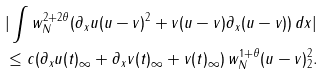Convert formula to latex. <formula><loc_0><loc_0><loc_500><loc_500>& | \int w _ { N } ^ { 2 + 2 \theta } ( \partial _ { x } u ( u - v ) ^ { 2 } + v ( u - v ) \partial _ { x } ( u - v ) ) \, d x | \\ & \leq c ( \| \partial _ { x } u ( t ) \| _ { \infty } + \| \partial _ { x } v ( t ) \| _ { \infty } + \| v ( t ) \| _ { \infty } ) \, \| w _ { N } ^ { 1 + \theta } ( u - v ) \| _ { 2 } ^ { 2 } .</formula> 